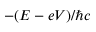<formula> <loc_0><loc_0><loc_500><loc_500>- ( E - e V ) / \hbar { c }</formula> 